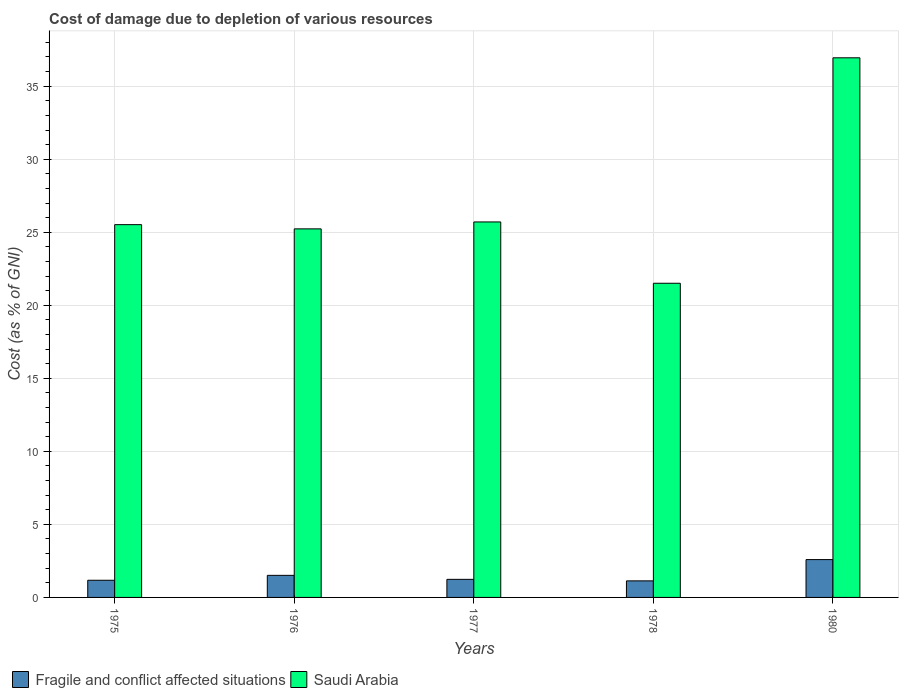How many different coloured bars are there?
Keep it short and to the point. 2. What is the label of the 5th group of bars from the left?
Your answer should be compact. 1980. In how many cases, is the number of bars for a given year not equal to the number of legend labels?
Your answer should be compact. 0. What is the cost of damage caused due to the depletion of various resources in Fragile and conflict affected situations in 1977?
Offer a very short reply. 1.24. Across all years, what is the maximum cost of damage caused due to the depletion of various resources in Saudi Arabia?
Your answer should be very brief. 36.94. Across all years, what is the minimum cost of damage caused due to the depletion of various resources in Fragile and conflict affected situations?
Ensure brevity in your answer.  1.13. In which year was the cost of damage caused due to the depletion of various resources in Saudi Arabia maximum?
Ensure brevity in your answer.  1980. In which year was the cost of damage caused due to the depletion of various resources in Saudi Arabia minimum?
Provide a succinct answer. 1978. What is the total cost of damage caused due to the depletion of various resources in Saudi Arabia in the graph?
Offer a terse response. 134.91. What is the difference between the cost of damage caused due to the depletion of various resources in Saudi Arabia in 1976 and that in 1978?
Provide a succinct answer. 3.72. What is the difference between the cost of damage caused due to the depletion of various resources in Fragile and conflict affected situations in 1978 and the cost of damage caused due to the depletion of various resources in Saudi Arabia in 1980?
Your response must be concise. -35.81. What is the average cost of damage caused due to the depletion of various resources in Fragile and conflict affected situations per year?
Provide a succinct answer. 1.53. In the year 1977, what is the difference between the cost of damage caused due to the depletion of various resources in Saudi Arabia and cost of damage caused due to the depletion of various resources in Fragile and conflict affected situations?
Offer a terse response. 24.47. In how many years, is the cost of damage caused due to the depletion of various resources in Fragile and conflict affected situations greater than 7 %?
Your response must be concise. 0. What is the ratio of the cost of damage caused due to the depletion of various resources in Fragile and conflict affected situations in 1975 to that in 1978?
Make the answer very short. 1.04. Is the cost of damage caused due to the depletion of various resources in Fragile and conflict affected situations in 1978 less than that in 1980?
Your answer should be compact. Yes. What is the difference between the highest and the second highest cost of damage caused due to the depletion of various resources in Saudi Arabia?
Your answer should be compact. 11.24. What is the difference between the highest and the lowest cost of damage caused due to the depletion of various resources in Saudi Arabia?
Ensure brevity in your answer.  15.43. In how many years, is the cost of damage caused due to the depletion of various resources in Fragile and conflict affected situations greater than the average cost of damage caused due to the depletion of various resources in Fragile and conflict affected situations taken over all years?
Provide a succinct answer. 1. Is the sum of the cost of damage caused due to the depletion of various resources in Saudi Arabia in 1977 and 1978 greater than the maximum cost of damage caused due to the depletion of various resources in Fragile and conflict affected situations across all years?
Your response must be concise. Yes. What does the 2nd bar from the left in 1980 represents?
Your response must be concise. Saudi Arabia. What does the 1st bar from the right in 1978 represents?
Give a very brief answer. Saudi Arabia. How many years are there in the graph?
Ensure brevity in your answer.  5. What is the difference between two consecutive major ticks on the Y-axis?
Your answer should be compact. 5. Does the graph contain grids?
Your answer should be compact. Yes. Where does the legend appear in the graph?
Ensure brevity in your answer.  Bottom left. How many legend labels are there?
Your answer should be very brief. 2. What is the title of the graph?
Your answer should be very brief. Cost of damage due to depletion of various resources. What is the label or title of the Y-axis?
Make the answer very short. Cost (as % of GNI). What is the Cost (as % of GNI) of Fragile and conflict affected situations in 1975?
Your response must be concise. 1.17. What is the Cost (as % of GNI) in Saudi Arabia in 1975?
Provide a succinct answer. 25.52. What is the Cost (as % of GNI) in Fragile and conflict affected situations in 1976?
Make the answer very short. 1.51. What is the Cost (as % of GNI) of Saudi Arabia in 1976?
Give a very brief answer. 25.23. What is the Cost (as % of GNI) in Fragile and conflict affected situations in 1977?
Keep it short and to the point. 1.24. What is the Cost (as % of GNI) in Saudi Arabia in 1977?
Your answer should be very brief. 25.71. What is the Cost (as % of GNI) of Fragile and conflict affected situations in 1978?
Your response must be concise. 1.13. What is the Cost (as % of GNI) of Saudi Arabia in 1978?
Your answer should be compact. 21.51. What is the Cost (as % of GNI) of Fragile and conflict affected situations in 1980?
Provide a succinct answer. 2.59. What is the Cost (as % of GNI) of Saudi Arabia in 1980?
Provide a short and direct response. 36.94. Across all years, what is the maximum Cost (as % of GNI) in Fragile and conflict affected situations?
Offer a very short reply. 2.59. Across all years, what is the maximum Cost (as % of GNI) of Saudi Arabia?
Your answer should be very brief. 36.94. Across all years, what is the minimum Cost (as % of GNI) in Fragile and conflict affected situations?
Your answer should be very brief. 1.13. Across all years, what is the minimum Cost (as % of GNI) in Saudi Arabia?
Keep it short and to the point. 21.51. What is the total Cost (as % of GNI) in Fragile and conflict affected situations in the graph?
Make the answer very short. 7.65. What is the total Cost (as % of GNI) of Saudi Arabia in the graph?
Offer a terse response. 134.91. What is the difference between the Cost (as % of GNI) of Fragile and conflict affected situations in 1975 and that in 1976?
Your answer should be compact. -0.34. What is the difference between the Cost (as % of GNI) of Saudi Arabia in 1975 and that in 1976?
Keep it short and to the point. 0.29. What is the difference between the Cost (as % of GNI) in Fragile and conflict affected situations in 1975 and that in 1977?
Provide a short and direct response. -0.06. What is the difference between the Cost (as % of GNI) in Saudi Arabia in 1975 and that in 1977?
Provide a succinct answer. -0.18. What is the difference between the Cost (as % of GNI) in Fragile and conflict affected situations in 1975 and that in 1978?
Offer a terse response. 0.04. What is the difference between the Cost (as % of GNI) in Saudi Arabia in 1975 and that in 1978?
Offer a very short reply. 4.01. What is the difference between the Cost (as % of GNI) in Fragile and conflict affected situations in 1975 and that in 1980?
Provide a succinct answer. -1.42. What is the difference between the Cost (as % of GNI) in Saudi Arabia in 1975 and that in 1980?
Your response must be concise. -11.42. What is the difference between the Cost (as % of GNI) of Fragile and conflict affected situations in 1976 and that in 1977?
Give a very brief answer. 0.27. What is the difference between the Cost (as % of GNI) in Saudi Arabia in 1976 and that in 1977?
Your answer should be compact. -0.47. What is the difference between the Cost (as % of GNI) in Fragile and conflict affected situations in 1976 and that in 1978?
Your answer should be compact. 0.38. What is the difference between the Cost (as % of GNI) of Saudi Arabia in 1976 and that in 1978?
Offer a very short reply. 3.72. What is the difference between the Cost (as % of GNI) in Fragile and conflict affected situations in 1976 and that in 1980?
Provide a succinct answer. -1.08. What is the difference between the Cost (as % of GNI) in Saudi Arabia in 1976 and that in 1980?
Provide a short and direct response. -11.71. What is the difference between the Cost (as % of GNI) in Fragile and conflict affected situations in 1977 and that in 1978?
Your answer should be compact. 0.1. What is the difference between the Cost (as % of GNI) of Saudi Arabia in 1977 and that in 1978?
Give a very brief answer. 4.2. What is the difference between the Cost (as % of GNI) in Fragile and conflict affected situations in 1977 and that in 1980?
Make the answer very short. -1.35. What is the difference between the Cost (as % of GNI) of Saudi Arabia in 1977 and that in 1980?
Your answer should be very brief. -11.24. What is the difference between the Cost (as % of GNI) in Fragile and conflict affected situations in 1978 and that in 1980?
Give a very brief answer. -1.46. What is the difference between the Cost (as % of GNI) in Saudi Arabia in 1978 and that in 1980?
Your answer should be very brief. -15.43. What is the difference between the Cost (as % of GNI) of Fragile and conflict affected situations in 1975 and the Cost (as % of GNI) of Saudi Arabia in 1976?
Your answer should be compact. -24.06. What is the difference between the Cost (as % of GNI) of Fragile and conflict affected situations in 1975 and the Cost (as % of GNI) of Saudi Arabia in 1977?
Provide a succinct answer. -24.53. What is the difference between the Cost (as % of GNI) of Fragile and conflict affected situations in 1975 and the Cost (as % of GNI) of Saudi Arabia in 1978?
Keep it short and to the point. -20.33. What is the difference between the Cost (as % of GNI) of Fragile and conflict affected situations in 1975 and the Cost (as % of GNI) of Saudi Arabia in 1980?
Give a very brief answer. -35.77. What is the difference between the Cost (as % of GNI) of Fragile and conflict affected situations in 1976 and the Cost (as % of GNI) of Saudi Arabia in 1977?
Make the answer very short. -24.19. What is the difference between the Cost (as % of GNI) in Fragile and conflict affected situations in 1976 and the Cost (as % of GNI) in Saudi Arabia in 1978?
Ensure brevity in your answer.  -20. What is the difference between the Cost (as % of GNI) of Fragile and conflict affected situations in 1976 and the Cost (as % of GNI) of Saudi Arabia in 1980?
Offer a terse response. -35.43. What is the difference between the Cost (as % of GNI) of Fragile and conflict affected situations in 1977 and the Cost (as % of GNI) of Saudi Arabia in 1978?
Offer a terse response. -20.27. What is the difference between the Cost (as % of GNI) of Fragile and conflict affected situations in 1977 and the Cost (as % of GNI) of Saudi Arabia in 1980?
Keep it short and to the point. -35.71. What is the difference between the Cost (as % of GNI) of Fragile and conflict affected situations in 1978 and the Cost (as % of GNI) of Saudi Arabia in 1980?
Offer a very short reply. -35.81. What is the average Cost (as % of GNI) of Fragile and conflict affected situations per year?
Keep it short and to the point. 1.53. What is the average Cost (as % of GNI) of Saudi Arabia per year?
Make the answer very short. 26.98. In the year 1975, what is the difference between the Cost (as % of GNI) of Fragile and conflict affected situations and Cost (as % of GNI) of Saudi Arabia?
Keep it short and to the point. -24.35. In the year 1976, what is the difference between the Cost (as % of GNI) of Fragile and conflict affected situations and Cost (as % of GNI) of Saudi Arabia?
Provide a succinct answer. -23.72. In the year 1977, what is the difference between the Cost (as % of GNI) in Fragile and conflict affected situations and Cost (as % of GNI) in Saudi Arabia?
Give a very brief answer. -24.47. In the year 1978, what is the difference between the Cost (as % of GNI) of Fragile and conflict affected situations and Cost (as % of GNI) of Saudi Arabia?
Keep it short and to the point. -20.37. In the year 1980, what is the difference between the Cost (as % of GNI) of Fragile and conflict affected situations and Cost (as % of GNI) of Saudi Arabia?
Your answer should be compact. -34.35. What is the ratio of the Cost (as % of GNI) in Fragile and conflict affected situations in 1975 to that in 1976?
Your response must be concise. 0.78. What is the ratio of the Cost (as % of GNI) of Saudi Arabia in 1975 to that in 1976?
Offer a very short reply. 1.01. What is the ratio of the Cost (as % of GNI) of Fragile and conflict affected situations in 1975 to that in 1977?
Make the answer very short. 0.95. What is the ratio of the Cost (as % of GNI) in Fragile and conflict affected situations in 1975 to that in 1978?
Provide a succinct answer. 1.04. What is the ratio of the Cost (as % of GNI) in Saudi Arabia in 1975 to that in 1978?
Your response must be concise. 1.19. What is the ratio of the Cost (as % of GNI) of Fragile and conflict affected situations in 1975 to that in 1980?
Your answer should be very brief. 0.45. What is the ratio of the Cost (as % of GNI) of Saudi Arabia in 1975 to that in 1980?
Offer a terse response. 0.69. What is the ratio of the Cost (as % of GNI) in Fragile and conflict affected situations in 1976 to that in 1977?
Make the answer very short. 1.22. What is the ratio of the Cost (as % of GNI) of Saudi Arabia in 1976 to that in 1977?
Your answer should be very brief. 0.98. What is the ratio of the Cost (as % of GNI) of Fragile and conflict affected situations in 1976 to that in 1978?
Provide a succinct answer. 1.33. What is the ratio of the Cost (as % of GNI) of Saudi Arabia in 1976 to that in 1978?
Ensure brevity in your answer.  1.17. What is the ratio of the Cost (as % of GNI) in Fragile and conflict affected situations in 1976 to that in 1980?
Your answer should be compact. 0.58. What is the ratio of the Cost (as % of GNI) of Saudi Arabia in 1976 to that in 1980?
Your answer should be compact. 0.68. What is the ratio of the Cost (as % of GNI) in Fragile and conflict affected situations in 1977 to that in 1978?
Offer a terse response. 1.09. What is the ratio of the Cost (as % of GNI) in Saudi Arabia in 1977 to that in 1978?
Give a very brief answer. 1.2. What is the ratio of the Cost (as % of GNI) in Fragile and conflict affected situations in 1977 to that in 1980?
Your answer should be compact. 0.48. What is the ratio of the Cost (as % of GNI) in Saudi Arabia in 1977 to that in 1980?
Ensure brevity in your answer.  0.7. What is the ratio of the Cost (as % of GNI) in Fragile and conflict affected situations in 1978 to that in 1980?
Offer a terse response. 0.44. What is the ratio of the Cost (as % of GNI) in Saudi Arabia in 1978 to that in 1980?
Keep it short and to the point. 0.58. What is the difference between the highest and the second highest Cost (as % of GNI) in Fragile and conflict affected situations?
Your answer should be very brief. 1.08. What is the difference between the highest and the second highest Cost (as % of GNI) of Saudi Arabia?
Your answer should be compact. 11.24. What is the difference between the highest and the lowest Cost (as % of GNI) of Fragile and conflict affected situations?
Your answer should be very brief. 1.46. What is the difference between the highest and the lowest Cost (as % of GNI) of Saudi Arabia?
Your answer should be very brief. 15.43. 